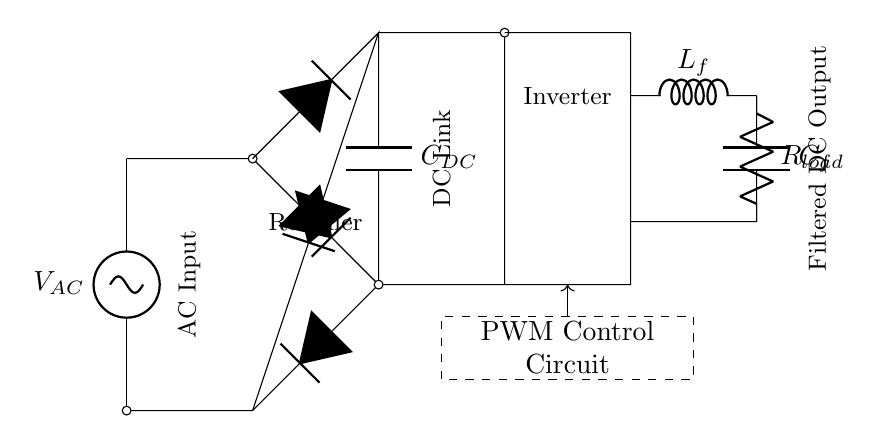What is the type of the AC source in this circuit? The AC source is labeled as V_AC, which indicates that it is an alternating current voltage source.
Answer: AC voltage source What component converts AC to DC in this circuit? The circuit has a bridge rectifier consisting of diodes that facilitates the conversion of AC voltage into DC voltage.
Answer: Bridge rectifier Which component is used to smooth the DC output? The circuit includes a DC link capacitor labeled C_DC, which is used to filter and smooth the output voltage from the rectifier.
Answer: C_DC What is the function of the PWM control circuit in this rectifier? The PWM control circuit modulates the output voltage and current by adjusting the width of the pulses, allowing for efficient power management and control of the inverter operation.
Answer: Modulation What is the role of the IGBT bridge in the circuit? The IGBT bridge serves to convert the rectified DC back to AC, controlling the output to the load with improved efficiency and precision.
Answer: Inverter How many inductors are present in the output filter section? The output filter section includes one inductor labeled L_f, which is crucial for reducing ripple in the DC output voltage.
Answer: One What does the load consist of in the circuit diagram? The load is represented by a resistor labeled R_load, indicating that it is the component that consumes the power supplied by the circuit.
Answer: R_load 